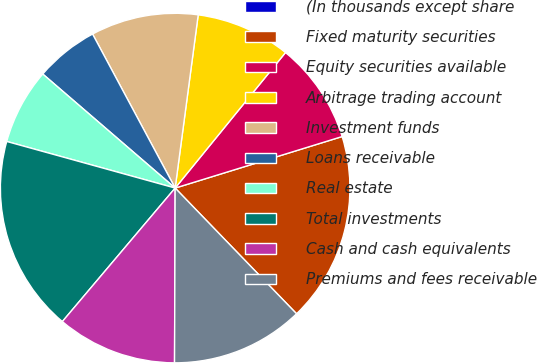Convert chart to OTSL. <chart><loc_0><loc_0><loc_500><loc_500><pie_chart><fcel>(In thousands except share<fcel>Fixed maturity securities<fcel>Equity securities available<fcel>Arbitrage trading account<fcel>Investment funds<fcel>Loans receivable<fcel>Real estate<fcel>Total investments<fcel>Cash and cash equivalents<fcel>Premiums and fees receivable<nl><fcel>0.0%<fcel>17.54%<fcel>9.36%<fcel>8.77%<fcel>9.94%<fcel>5.85%<fcel>7.02%<fcel>18.13%<fcel>11.11%<fcel>12.28%<nl></chart> 